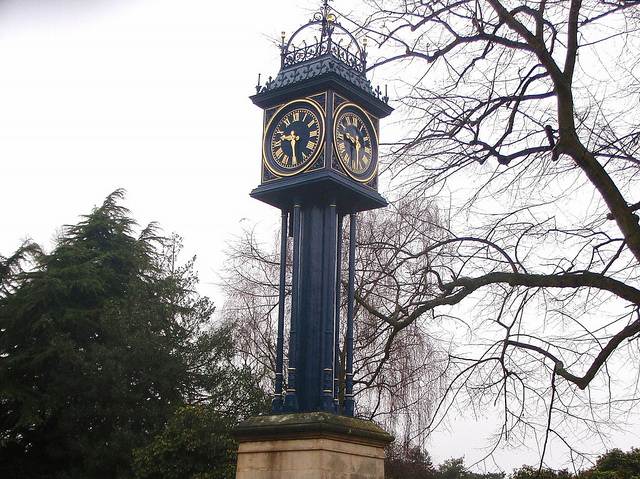The number on this clock face are known as what type of numerals?
Answer the question using a single word or phrase. Roman 